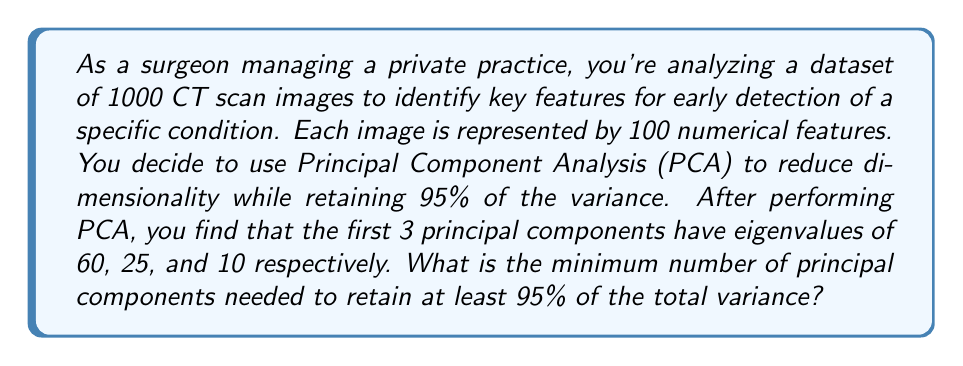Provide a solution to this math problem. To solve this problem, we need to follow these steps:

1) First, let's recall that in PCA, the total variance is equal to the sum of all eigenvalues.

2) We're given the first three eigenvalues: 60, 25, and 10. Let's calculate their sum:

   $$ 60 + 25 + 10 = 95 $$

3) Now, we need to determine what percentage of the total variance these three components represent. To do this, we need to know the total variance (sum of all eigenvalues).

4) In PCA, when working with standardized data (which is typical), the total variance equals the number of original features. In this case, we had 100 features, so the total variance is 100.

5) Let's calculate the percentage of variance explained by the first three components:

   $$ \frac{95}{100} \times 100\% = 95\% $$

6) We see that the first three principal components exactly account for 95% of the total variance.

7) The question asks for the minimum number of components needed to retain at least 95% of the variance. Since the first three components together explain exactly 95%, we need all three of them to meet this threshold.

Therefore, the minimum number of principal components needed is 3.
Answer: 3 principal components 